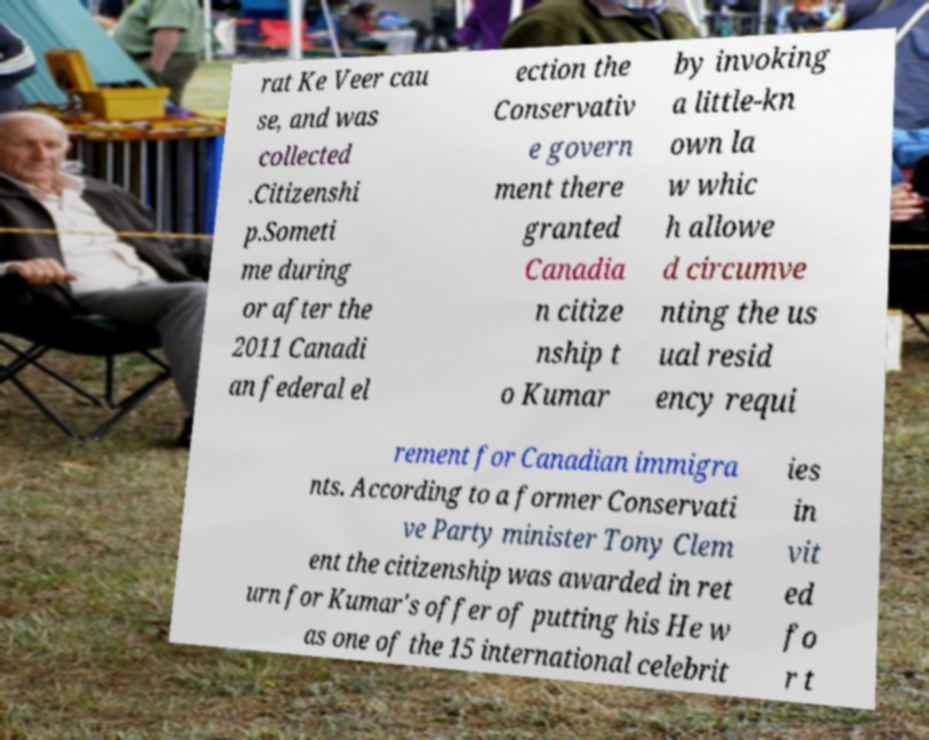Can you read and provide the text displayed in the image?This photo seems to have some interesting text. Can you extract and type it out for me? rat Ke Veer cau se, and was collected .Citizenshi p.Someti me during or after the 2011 Canadi an federal el ection the Conservativ e govern ment there granted Canadia n citize nship t o Kumar by invoking a little-kn own la w whic h allowe d circumve nting the us ual resid ency requi rement for Canadian immigra nts. According to a former Conservati ve Party minister Tony Clem ent the citizenship was awarded in ret urn for Kumar's offer of putting his He w as one of the 15 international celebrit ies in vit ed fo r t 